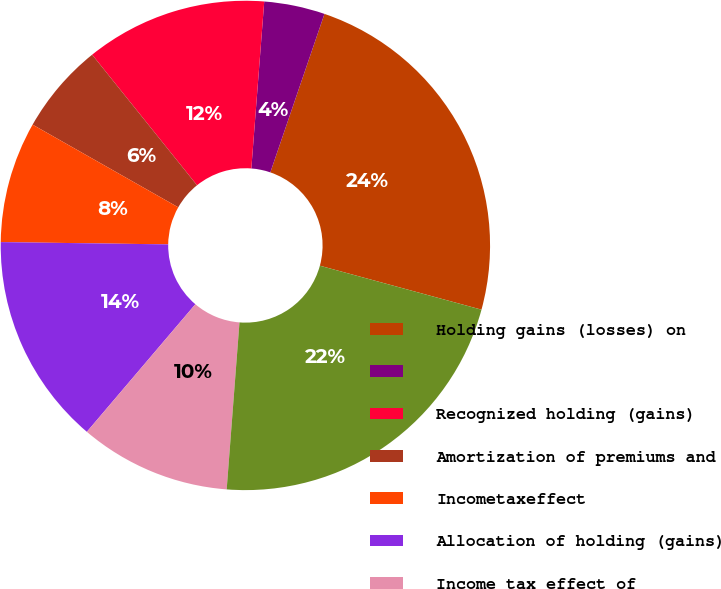Convert chart to OTSL. <chart><loc_0><loc_0><loc_500><loc_500><pie_chart><fcel>Holding gains (losses) on<fcel>Unnamed: 1<fcel>Recognized holding (gains)<fcel>Amortization of premiums and<fcel>Incometaxeffect<fcel>Allocation of holding (gains)<fcel>Income tax effect of<fcel>Net unrealized investment<nl><fcel>23.99%<fcel>4.01%<fcel>12.0%<fcel>6.01%<fcel>8.0%<fcel>14.0%<fcel>10.0%<fcel>21.99%<nl></chart> 